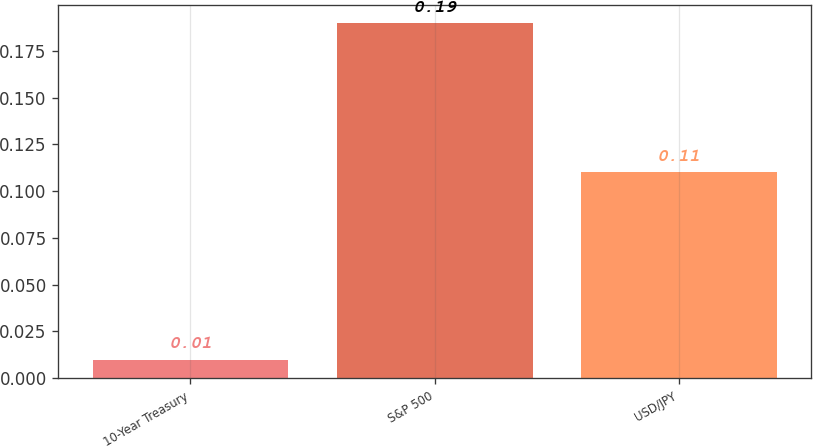Convert chart to OTSL. <chart><loc_0><loc_0><loc_500><loc_500><bar_chart><fcel>10-Year Treasury<fcel>S&P 500<fcel>USD/JPY<nl><fcel>0.01<fcel>0.19<fcel>0.11<nl></chart> 